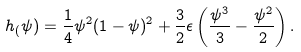Convert formula to latex. <formula><loc_0><loc_0><loc_500><loc_500>h _ { ( } \psi ) = \frac { 1 } { 4 } \psi ^ { 2 } ( 1 - \psi ) ^ { 2 } + \frac { 3 } { 2 } \epsilon \left ( \frac { \psi ^ { 3 } } { 3 } - \frac { \psi ^ { 2 } } { 2 } \right ) .</formula> 